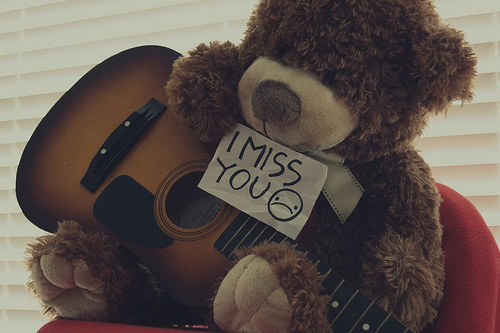Please transcribe the text information in this image. I MISS YOU 